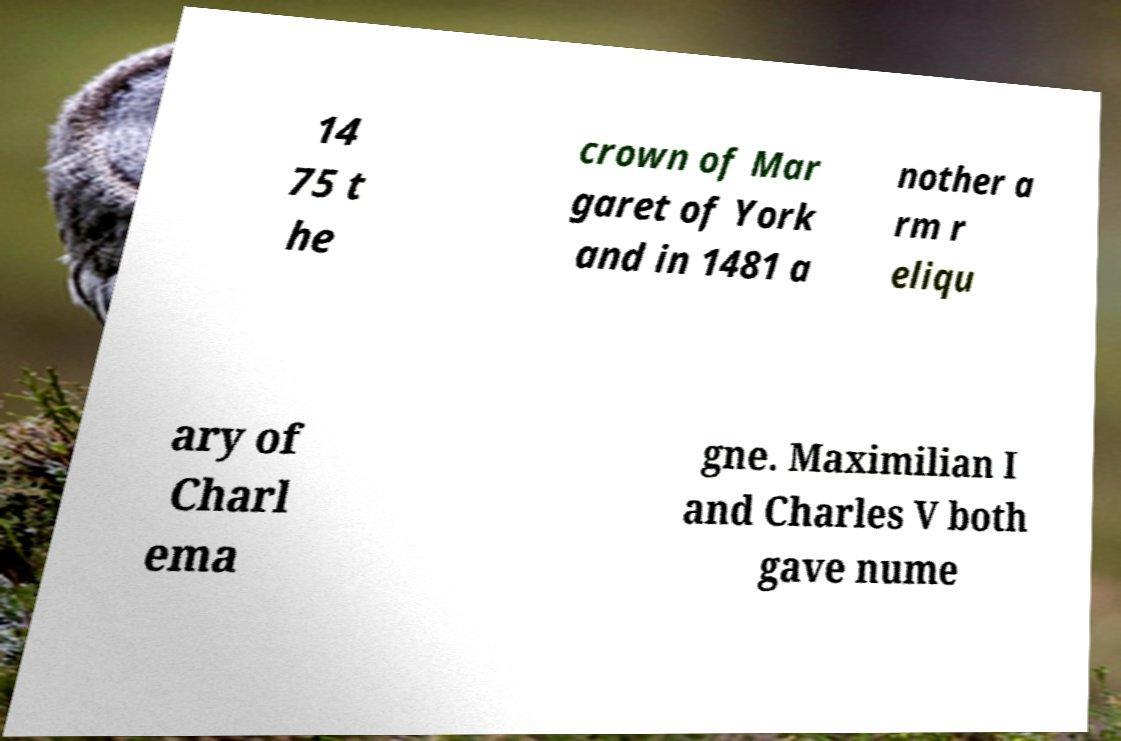What messages or text are displayed in this image? I need them in a readable, typed format. 14 75 t he crown of Mar garet of York and in 1481 a nother a rm r eliqu ary of Charl ema gne. Maximilian I and Charles V both gave nume 